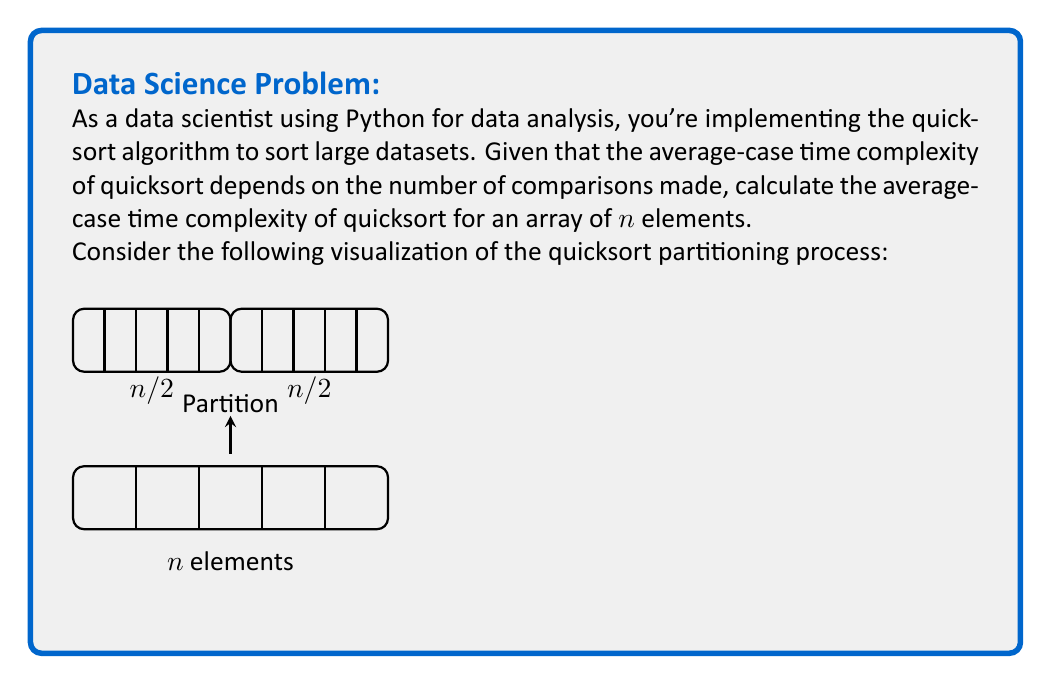Show me your answer to this math problem. To calculate the average-case time complexity of quicksort, we need to consider the following steps:

1) In the average case, quicksort partitions the array into two roughly equal halves at each step.

2) The partitioning process itself takes $O(n)$ time, where n is the number of elements in the current subarray.

3) We can express the recurrence relation for the average-case time complexity T(n) as:

   $$T(n) = 2T(n/2) + O(n)$$

4) This recurrence relation can be solved using the Master Theorem. The Master Theorem states that for a recurrence of the form:

   $$T(n) = aT(n/b) + f(n)$$

   where $a \geq 1$, $b > 1$, and $f(n)$ is a positive function, the solution depends on comparing $f(n)$ with $n^{\log_b a}$.

5) In our case, $a = 2$, $b = 2$, and $f(n) = O(n)$.

6) We calculate $n^{\log_b a}$:
   
   $$n^{\log_2 2} = n^1 = n$$

7) Since $f(n) = O(n)$ and $n^{\log_b a} = n$, we have the case where $f(n) = \Theta(n^{\log_b a})$.

8) According to the Master Theorem, when $f(n) = \Theta(n^{\log_b a})$, the solution is:

   $$T(n) = \Theta(n^{\log_b a} \log n) = \Theta(n \log n)$$

Therefore, the average-case time complexity of quicksort is $\Theta(n \log n)$.
Answer: $\Theta(n \log n)$ 